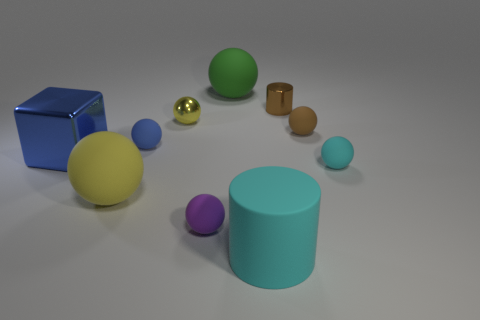Is the number of big green rubber spheres greater than the number of blue things?
Give a very brief answer. No. Does the small brown rubber object have the same shape as the small cyan matte object?
Give a very brief answer. Yes. What material is the blue sphere behind the big rubber ball that is in front of the green matte ball?
Keep it short and to the point. Rubber. Do the green rubber sphere and the purple sphere have the same size?
Offer a terse response. No. There is a large sphere in front of the small yellow metal object; is there a brown sphere behind it?
Provide a succinct answer. Yes. What is the size of the matte sphere that is the same color as the shiny cylinder?
Give a very brief answer. Small. There is a cyan matte thing left of the small cyan ball; what shape is it?
Provide a succinct answer. Cylinder. There is a object that is left of the yellow ball to the left of the tiny metal ball; what number of brown things are left of it?
Keep it short and to the point. 0. Is the size of the rubber cylinder the same as the object that is to the left of the big yellow rubber thing?
Your answer should be very brief. Yes. There is a shiny thing to the left of the big rubber ball in front of the large blue metallic object; what size is it?
Give a very brief answer. Large. 